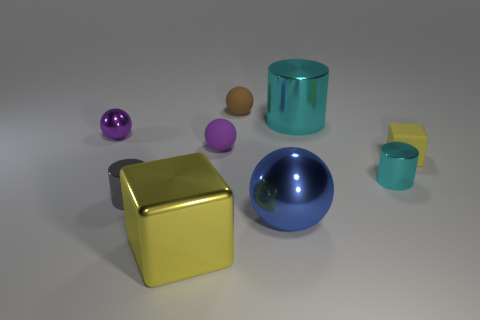Subtract 1 spheres. How many spheres are left? 3 Subtract all green spheres. Subtract all gray cylinders. How many spheres are left? 4 Add 1 small gray cylinders. How many objects exist? 10 Subtract all cylinders. How many objects are left? 6 Subtract all large brown metal cylinders. Subtract all metallic spheres. How many objects are left? 7 Add 1 large cyan cylinders. How many large cyan cylinders are left? 2 Add 1 small brown matte objects. How many small brown matte objects exist? 2 Subtract 0 brown cylinders. How many objects are left? 9 